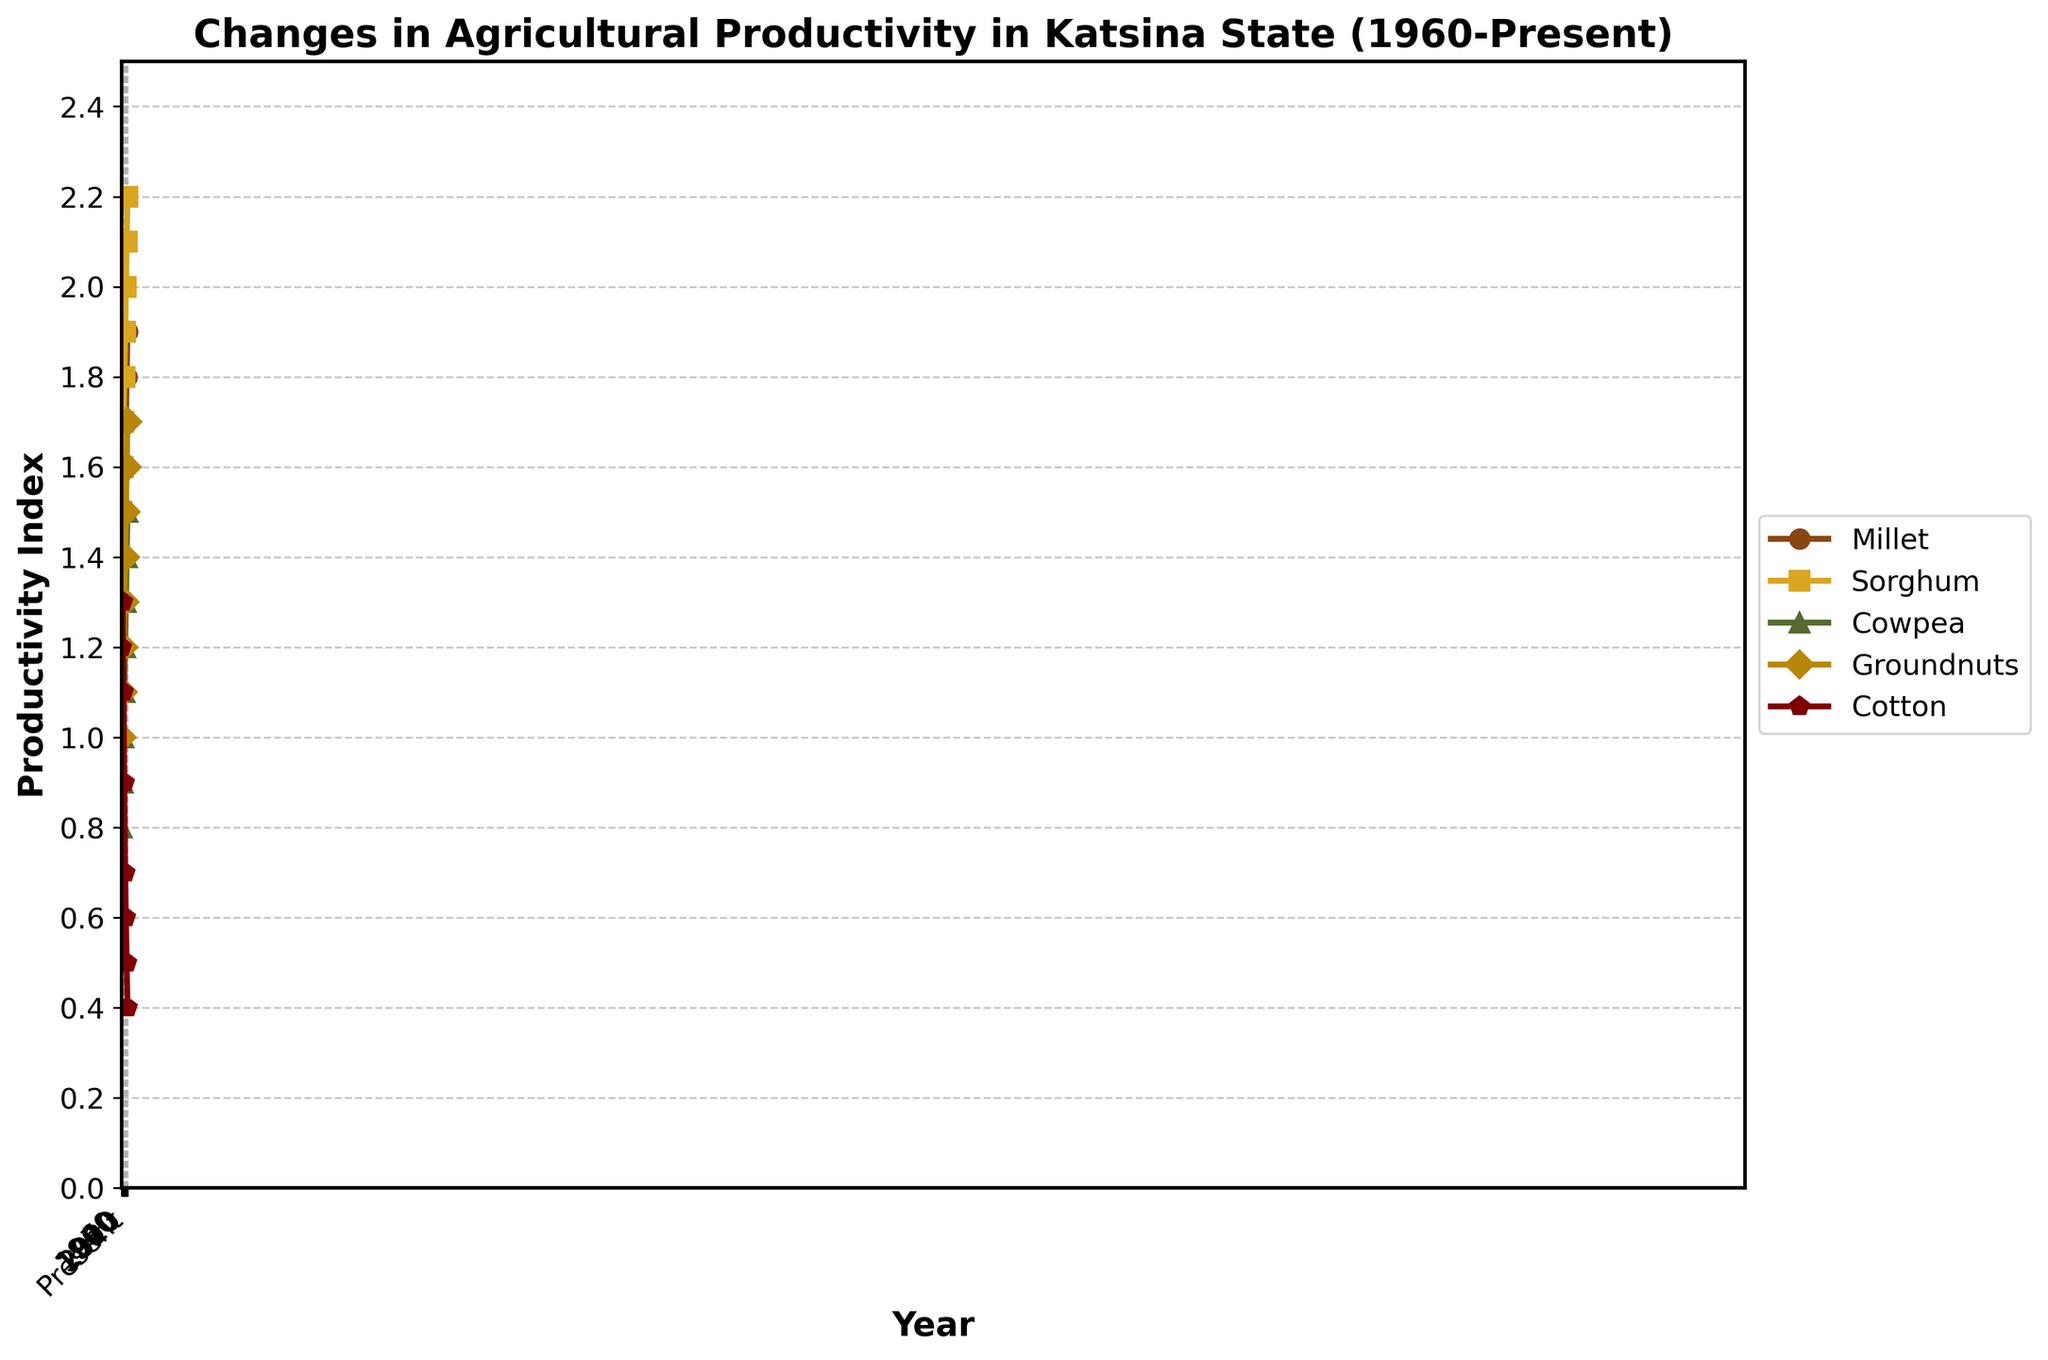What is the trend of sorghum productivity from 1960 to present? To observe the trend, look at the sorghum line on the graph which is marked by a particular color and marker. Notice that it consistently rises from 1.5 in 1960 to 2.2 in the present year.
Answer: Consistently rising Which crop showed the largest decrease in productivity over the years? Compare the decline in productivity for all crops by observing their end points on the y-axis. Cotton's productivity decreased dramatically from 1.2 to 0.4.
Answer: Cotton How does the Millet productivity in 1990 compare to the Cowpea productivity in the same year? Locate the points on the graph for Millet and Cowpea in 1990. Millet's productivity is 1.5, while Cowpea's productivity is 1.1. Compare these two values.
Answer: Millet is higher Calculate the average productivity of Groundnuts in the decades shown. Sum up the values of Groundnuts from 1960 to present (1.0 + 1.1 + 1.2 + 1.3 + 1.4 + 1.5 + 1.6 + 1.7) which is 10.8. Divide this sum by the number of decades, which is 8.
Answer: 1.35 Which crop had the smallest change in productivity from 1960 to the present? Examine the initial and final points for each crop to see the total change over the period. Millet rose from 1.2 to 1.9, which is a change of 0.7, the smallest among the crops.
Answer: Millet What is the visual representation (color) used for representing Cotton's productivity? Identify the line representing Cotton and note its color from the figure's legend.
Answer: Brown Compare the productivity of Sorghum in 1980 and Groundnuts in 2020. Check the y-values for Sorghum in 1980 and Groundnuts in 2020. Sorghum's value is 1.7 and Groundnuts' value is 1.6.
Answer: Sorghum is higher What is the combined productivity of Cowpea and Groundnuts in 2000? Find the productivity values for Cowpea and Groundnuts in 2000, which are 1.2 and 1.4 respectively. Sum these values: 1.2 + 1.4 = 2.6.
Answer: 2.6 Which year did all the crops show an increasing trend in productivity compared to 1960? Review the dataset and the visual for each crop and compare the values year by year starting from 1960. All crops show an increasing trend in each year over 1960, but particularly substantial upticks can be seen in year 2000.
Answer: 2000 How does the productivity index of Millet in the year 2020 compare to that in 2010? Check the graph for Millet's productivity values in the years 2010 (1.7) and 2020 (1.8) and compare. This reveals a slight increase of 0.1.
Answer: Slightly increased 